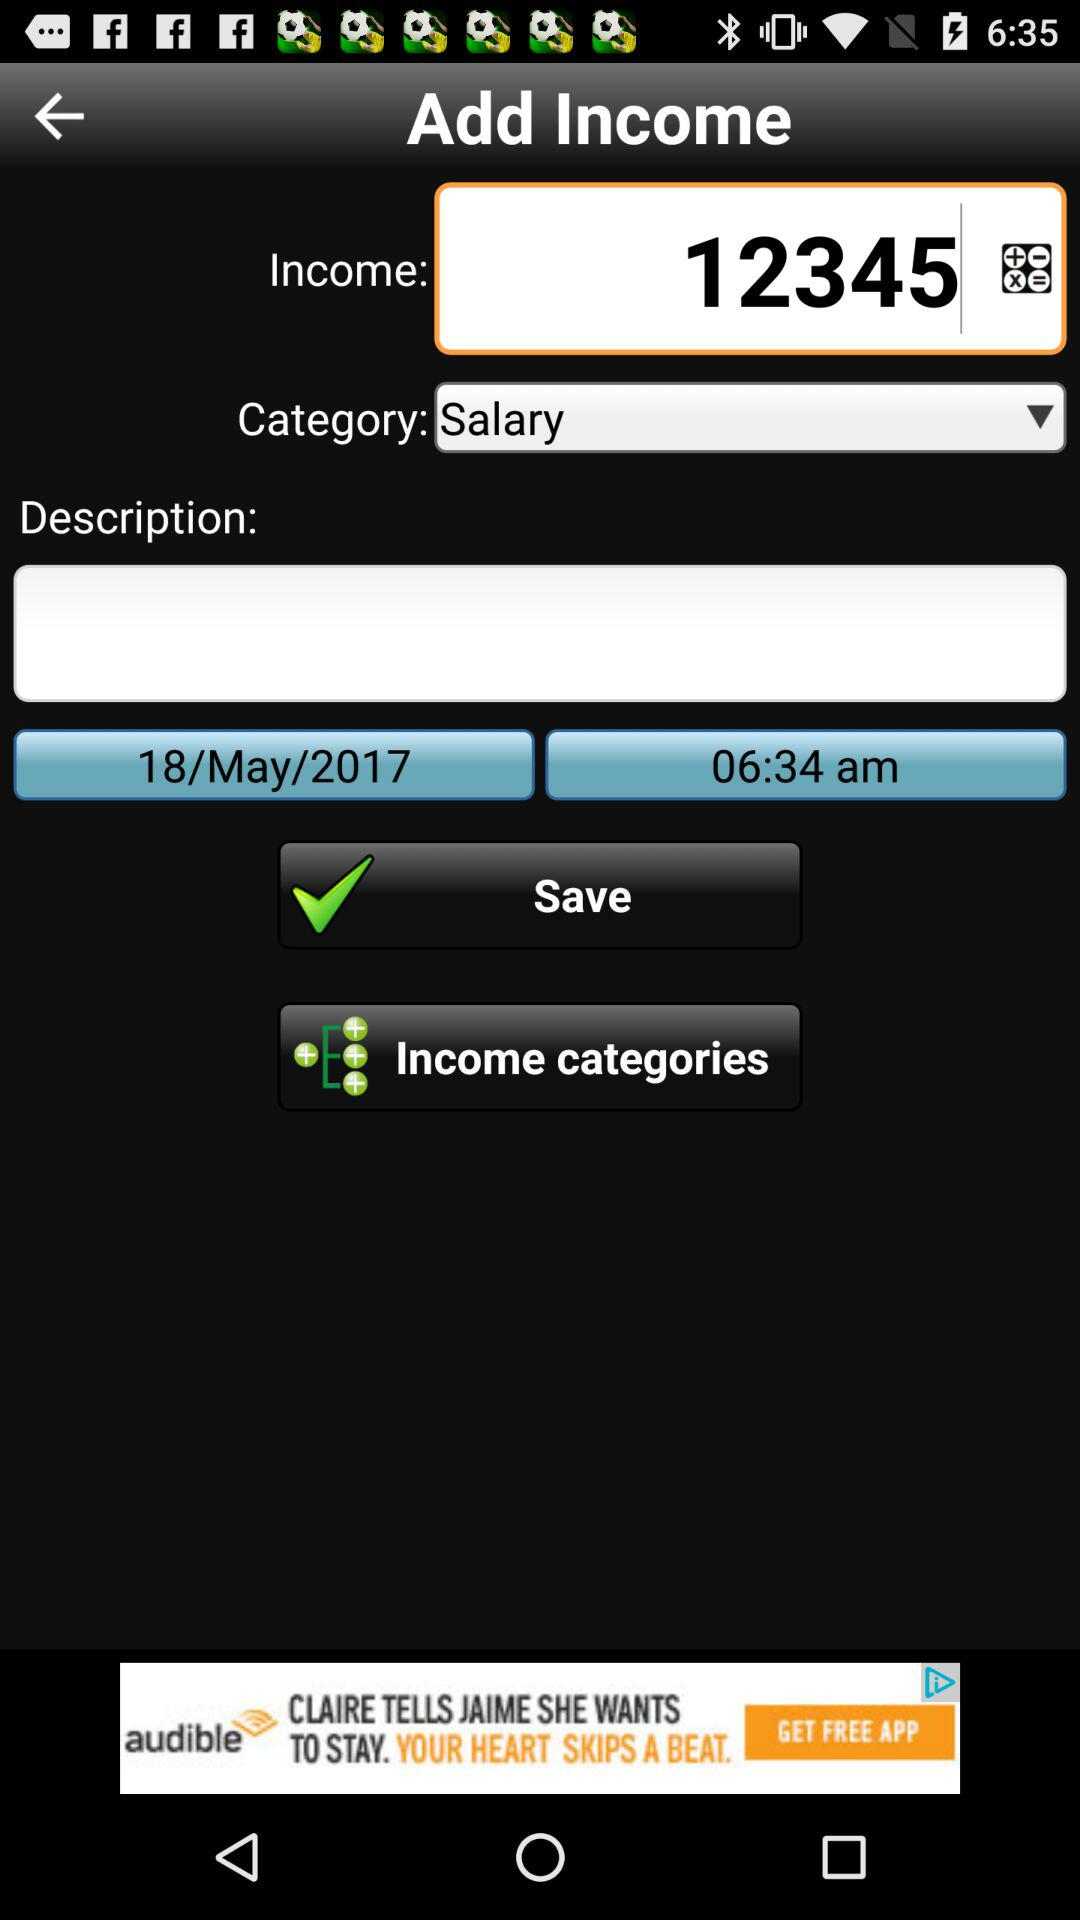What is the selected "Category"? The selected "Category" is salary. 